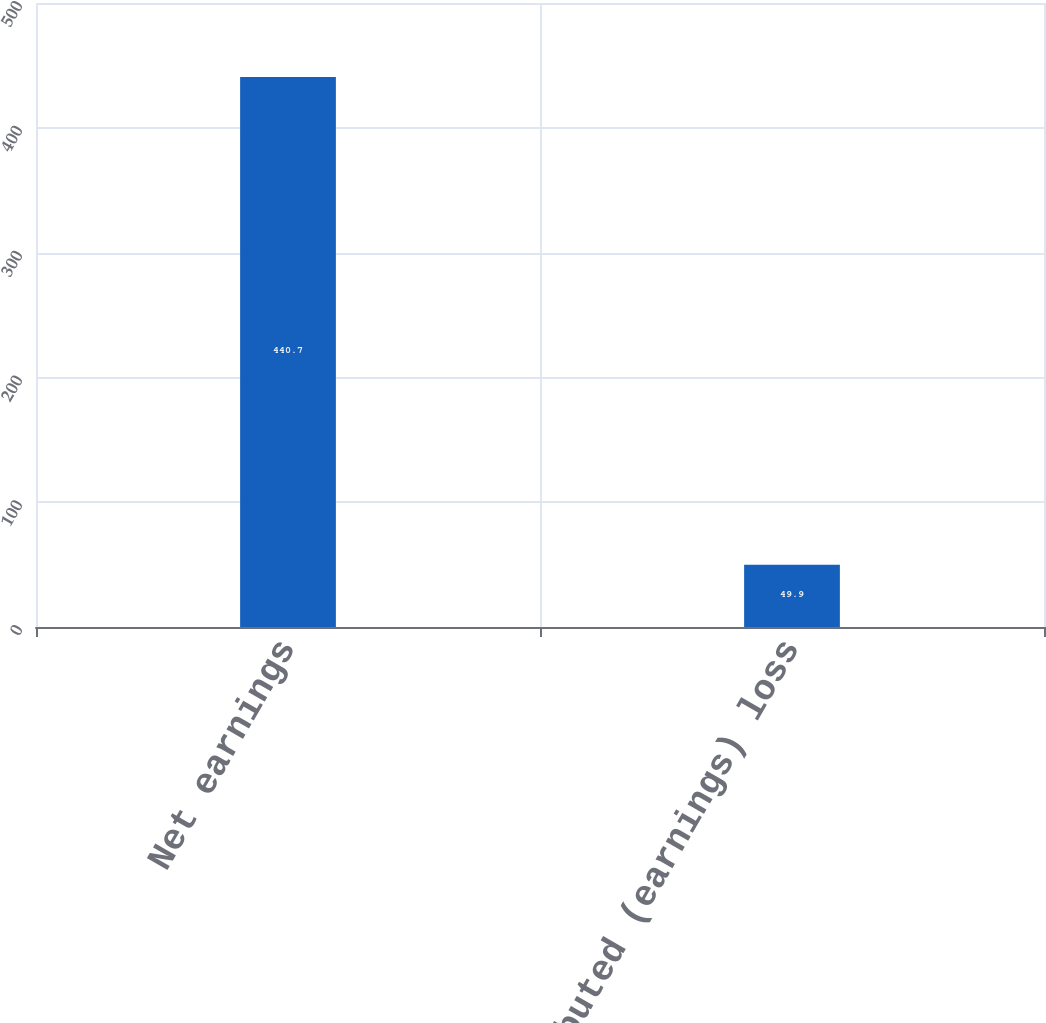<chart> <loc_0><loc_0><loc_500><loc_500><bar_chart><fcel>Net earnings<fcel>Undistributed (earnings) loss<nl><fcel>440.7<fcel>49.9<nl></chart> 